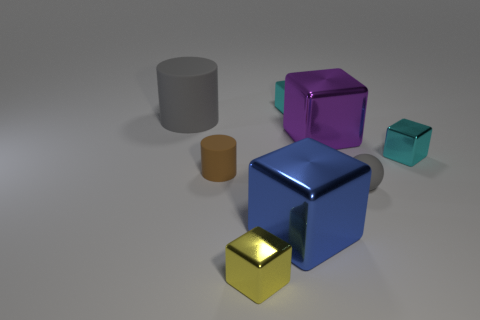Subtract all yellow metallic blocks. How many blocks are left? 4 Subtract 3 cubes. How many cubes are left? 2 Subtract all blue cubes. How many cubes are left? 4 Subtract all red blocks. Subtract all red spheres. How many blocks are left? 5 Add 2 green cubes. How many objects exist? 10 Subtract all spheres. How many objects are left? 7 Add 1 tiny gray rubber things. How many tiny gray rubber things exist? 2 Subtract 0 cyan cylinders. How many objects are left? 8 Subtract all purple metal blocks. Subtract all big red cylinders. How many objects are left? 7 Add 2 cyan metallic blocks. How many cyan metallic blocks are left? 4 